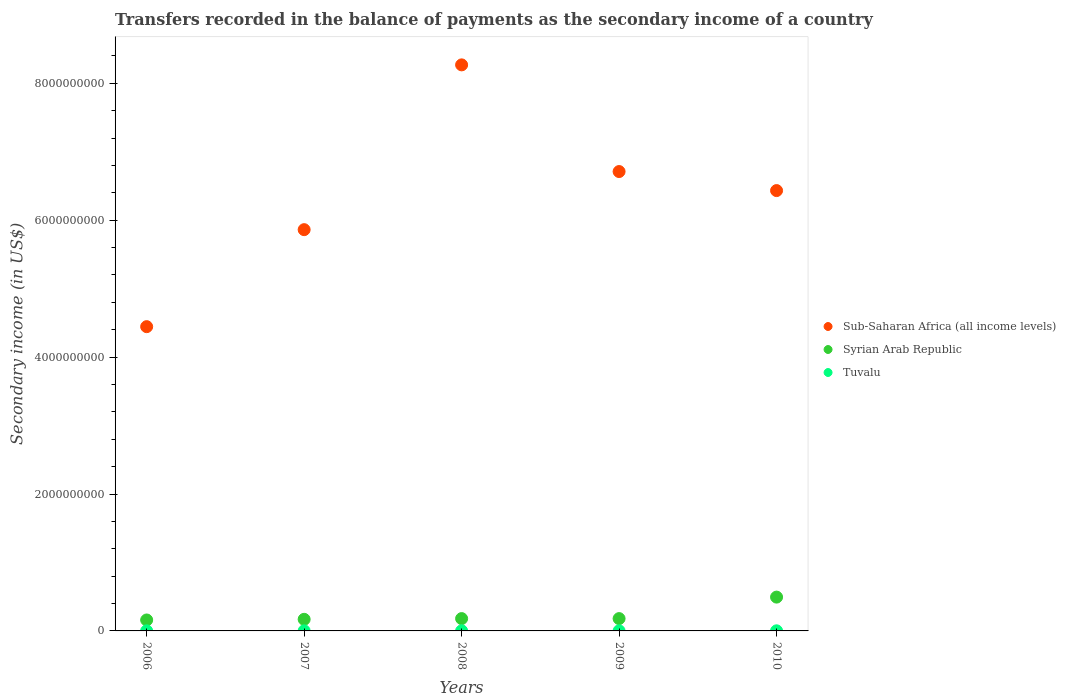How many different coloured dotlines are there?
Offer a terse response. 3. What is the secondary income of in Syrian Arab Republic in 2009?
Provide a succinct answer. 1.80e+08. Across all years, what is the maximum secondary income of in Tuvalu?
Your answer should be very brief. 1.61e+06. Across all years, what is the minimum secondary income of in Sub-Saharan Africa (all income levels)?
Make the answer very short. 4.45e+09. In which year was the secondary income of in Sub-Saharan Africa (all income levels) maximum?
Ensure brevity in your answer.  2008. In which year was the secondary income of in Tuvalu minimum?
Provide a succinct answer. 2006. What is the total secondary income of in Tuvalu in the graph?
Keep it short and to the point. 6.92e+06. What is the difference between the secondary income of in Sub-Saharan Africa (all income levels) in 2006 and that in 2010?
Offer a terse response. -1.99e+09. What is the difference between the secondary income of in Tuvalu in 2007 and the secondary income of in Sub-Saharan Africa (all income levels) in 2010?
Your answer should be very brief. -6.43e+09. What is the average secondary income of in Sub-Saharan Africa (all income levels) per year?
Offer a very short reply. 6.34e+09. In the year 2006, what is the difference between the secondary income of in Tuvalu and secondary income of in Sub-Saharan Africa (all income levels)?
Provide a short and direct response. -4.44e+09. In how many years, is the secondary income of in Syrian Arab Republic greater than 800000000 US$?
Your answer should be compact. 0. What is the ratio of the secondary income of in Syrian Arab Republic in 2006 to that in 2008?
Offer a terse response. 0.89. Is the secondary income of in Sub-Saharan Africa (all income levels) in 2006 less than that in 2007?
Offer a very short reply. Yes. What is the difference between the highest and the second highest secondary income of in Syrian Arab Republic?
Give a very brief answer. 3.14e+08. What is the difference between the highest and the lowest secondary income of in Tuvalu?
Offer a terse response. 4.24e+05. In how many years, is the secondary income of in Sub-Saharan Africa (all income levels) greater than the average secondary income of in Sub-Saharan Africa (all income levels) taken over all years?
Your answer should be compact. 3. Is the sum of the secondary income of in Syrian Arab Republic in 2006 and 2007 greater than the maximum secondary income of in Tuvalu across all years?
Your answer should be compact. Yes. Is the secondary income of in Sub-Saharan Africa (all income levels) strictly less than the secondary income of in Tuvalu over the years?
Make the answer very short. No. How many dotlines are there?
Keep it short and to the point. 3. How many years are there in the graph?
Offer a terse response. 5. Are the values on the major ticks of Y-axis written in scientific E-notation?
Your response must be concise. No. Does the graph contain grids?
Offer a terse response. No. How are the legend labels stacked?
Offer a terse response. Vertical. What is the title of the graph?
Your answer should be compact. Transfers recorded in the balance of payments as the secondary income of a country. Does "Burkina Faso" appear as one of the legend labels in the graph?
Your answer should be compact. No. What is the label or title of the X-axis?
Provide a succinct answer. Years. What is the label or title of the Y-axis?
Your answer should be compact. Secondary income (in US$). What is the Secondary income (in US$) in Sub-Saharan Africa (all income levels) in 2006?
Provide a succinct answer. 4.45e+09. What is the Secondary income (in US$) in Syrian Arab Republic in 2006?
Your answer should be very brief. 1.60e+08. What is the Secondary income (in US$) in Tuvalu in 2006?
Give a very brief answer. 1.19e+06. What is the Secondary income (in US$) of Sub-Saharan Africa (all income levels) in 2007?
Your answer should be compact. 5.86e+09. What is the Secondary income (in US$) of Syrian Arab Republic in 2007?
Offer a terse response. 1.70e+08. What is the Secondary income (in US$) in Tuvalu in 2007?
Provide a short and direct response. 1.32e+06. What is the Secondary income (in US$) in Sub-Saharan Africa (all income levels) in 2008?
Give a very brief answer. 8.27e+09. What is the Secondary income (in US$) in Syrian Arab Republic in 2008?
Make the answer very short. 1.80e+08. What is the Secondary income (in US$) of Tuvalu in 2008?
Offer a terse response. 1.46e+06. What is the Secondary income (in US$) of Sub-Saharan Africa (all income levels) in 2009?
Your response must be concise. 6.71e+09. What is the Secondary income (in US$) of Syrian Arab Republic in 2009?
Ensure brevity in your answer.  1.80e+08. What is the Secondary income (in US$) of Tuvalu in 2009?
Provide a short and direct response. 1.33e+06. What is the Secondary income (in US$) of Sub-Saharan Africa (all income levels) in 2010?
Your answer should be very brief. 6.43e+09. What is the Secondary income (in US$) of Syrian Arab Republic in 2010?
Ensure brevity in your answer.  4.94e+08. What is the Secondary income (in US$) of Tuvalu in 2010?
Your answer should be compact. 1.61e+06. Across all years, what is the maximum Secondary income (in US$) of Sub-Saharan Africa (all income levels)?
Your answer should be very brief. 8.27e+09. Across all years, what is the maximum Secondary income (in US$) of Syrian Arab Republic?
Provide a succinct answer. 4.94e+08. Across all years, what is the maximum Secondary income (in US$) in Tuvalu?
Ensure brevity in your answer.  1.61e+06. Across all years, what is the minimum Secondary income (in US$) of Sub-Saharan Africa (all income levels)?
Make the answer very short. 4.45e+09. Across all years, what is the minimum Secondary income (in US$) of Syrian Arab Republic?
Offer a very short reply. 1.60e+08. Across all years, what is the minimum Secondary income (in US$) in Tuvalu?
Your answer should be compact. 1.19e+06. What is the total Secondary income (in US$) of Sub-Saharan Africa (all income levels) in the graph?
Provide a short and direct response. 3.17e+1. What is the total Secondary income (in US$) of Syrian Arab Republic in the graph?
Provide a short and direct response. 1.18e+09. What is the total Secondary income (in US$) of Tuvalu in the graph?
Keep it short and to the point. 6.92e+06. What is the difference between the Secondary income (in US$) of Sub-Saharan Africa (all income levels) in 2006 and that in 2007?
Provide a succinct answer. -1.42e+09. What is the difference between the Secondary income (in US$) of Syrian Arab Republic in 2006 and that in 2007?
Provide a succinct answer. -9.50e+06. What is the difference between the Secondary income (in US$) in Tuvalu in 2006 and that in 2007?
Keep it short and to the point. -1.27e+05. What is the difference between the Secondary income (in US$) in Sub-Saharan Africa (all income levels) in 2006 and that in 2008?
Offer a very short reply. -3.82e+09. What is the difference between the Secondary income (in US$) in Syrian Arab Republic in 2006 and that in 2008?
Provide a short and direct response. -2.00e+07. What is the difference between the Secondary income (in US$) of Tuvalu in 2006 and that in 2008?
Keep it short and to the point. -2.72e+05. What is the difference between the Secondary income (in US$) in Sub-Saharan Africa (all income levels) in 2006 and that in 2009?
Provide a short and direct response. -2.27e+09. What is the difference between the Secondary income (in US$) of Syrian Arab Republic in 2006 and that in 2009?
Provide a succinct answer. -2.00e+07. What is the difference between the Secondary income (in US$) in Tuvalu in 2006 and that in 2009?
Your answer should be compact. -1.44e+05. What is the difference between the Secondary income (in US$) of Sub-Saharan Africa (all income levels) in 2006 and that in 2010?
Offer a very short reply. -1.99e+09. What is the difference between the Secondary income (in US$) of Syrian Arab Republic in 2006 and that in 2010?
Offer a very short reply. -3.34e+08. What is the difference between the Secondary income (in US$) in Tuvalu in 2006 and that in 2010?
Make the answer very short. -4.24e+05. What is the difference between the Secondary income (in US$) of Sub-Saharan Africa (all income levels) in 2007 and that in 2008?
Your answer should be compact. -2.41e+09. What is the difference between the Secondary income (in US$) of Syrian Arab Republic in 2007 and that in 2008?
Keep it short and to the point. -1.05e+07. What is the difference between the Secondary income (in US$) of Tuvalu in 2007 and that in 2008?
Your answer should be very brief. -1.44e+05. What is the difference between the Secondary income (in US$) of Sub-Saharan Africa (all income levels) in 2007 and that in 2009?
Keep it short and to the point. -8.49e+08. What is the difference between the Secondary income (in US$) of Syrian Arab Republic in 2007 and that in 2009?
Offer a very short reply. -1.05e+07. What is the difference between the Secondary income (in US$) in Tuvalu in 2007 and that in 2009?
Offer a very short reply. -1.69e+04. What is the difference between the Secondary income (in US$) in Sub-Saharan Africa (all income levels) in 2007 and that in 2010?
Give a very brief answer. -5.71e+08. What is the difference between the Secondary income (in US$) of Syrian Arab Republic in 2007 and that in 2010?
Offer a very short reply. -3.24e+08. What is the difference between the Secondary income (in US$) of Tuvalu in 2007 and that in 2010?
Provide a short and direct response. -2.97e+05. What is the difference between the Secondary income (in US$) in Sub-Saharan Africa (all income levels) in 2008 and that in 2009?
Your answer should be very brief. 1.56e+09. What is the difference between the Secondary income (in US$) of Syrian Arab Republic in 2008 and that in 2009?
Ensure brevity in your answer.  0. What is the difference between the Secondary income (in US$) in Tuvalu in 2008 and that in 2009?
Provide a succinct answer. 1.27e+05. What is the difference between the Secondary income (in US$) of Sub-Saharan Africa (all income levels) in 2008 and that in 2010?
Provide a short and direct response. 1.84e+09. What is the difference between the Secondary income (in US$) in Syrian Arab Republic in 2008 and that in 2010?
Provide a succinct answer. -3.14e+08. What is the difference between the Secondary income (in US$) in Tuvalu in 2008 and that in 2010?
Keep it short and to the point. -1.53e+05. What is the difference between the Secondary income (in US$) of Sub-Saharan Africa (all income levels) in 2009 and that in 2010?
Make the answer very short. 2.78e+08. What is the difference between the Secondary income (in US$) of Syrian Arab Republic in 2009 and that in 2010?
Give a very brief answer. -3.14e+08. What is the difference between the Secondary income (in US$) in Tuvalu in 2009 and that in 2010?
Make the answer very short. -2.80e+05. What is the difference between the Secondary income (in US$) of Sub-Saharan Africa (all income levels) in 2006 and the Secondary income (in US$) of Syrian Arab Republic in 2007?
Offer a very short reply. 4.28e+09. What is the difference between the Secondary income (in US$) in Sub-Saharan Africa (all income levels) in 2006 and the Secondary income (in US$) in Tuvalu in 2007?
Offer a very short reply. 4.44e+09. What is the difference between the Secondary income (in US$) of Syrian Arab Republic in 2006 and the Secondary income (in US$) of Tuvalu in 2007?
Offer a very short reply. 1.59e+08. What is the difference between the Secondary income (in US$) in Sub-Saharan Africa (all income levels) in 2006 and the Secondary income (in US$) in Syrian Arab Republic in 2008?
Ensure brevity in your answer.  4.27e+09. What is the difference between the Secondary income (in US$) of Sub-Saharan Africa (all income levels) in 2006 and the Secondary income (in US$) of Tuvalu in 2008?
Provide a short and direct response. 4.44e+09. What is the difference between the Secondary income (in US$) of Syrian Arab Republic in 2006 and the Secondary income (in US$) of Tuvalu in 2008?
Keep it short and to the point. 1.59e+08. What is the difference between the Secondary income (in US$) of Sub-Saharan Africa (all income levels) in 2006 and the Secondary income (in US$) of Syrian Arab Republic in 2009?
Provide a succinct answer. 4.27e+09. What is the difference between the Secondary income (in US$) in Sub-Saharan Africa (all income levels) in 2006 and the Secondary income (in US$) in Tuvalu in 2009?
Your answer should be compact. 4.44e+09. What is the difference between the Secondary income (in US$) of Syrian Arab Republic in 2006 and the Secondary income (in US$) of Tuvalu in 2009?
Offer a terse response. 1.59e+08. What is the difference between the Secondary income (in US$) in Sub-Saharan Africa (all income levels) in 2006 and the Secondary income (in US$) in Syrian Arab Republic in 2010?
Keep it short and to the point. 3.95e+09. What is the difference between the Secondary income (in US$) in Sub-Saharan Africa (all income levels) in 2006 and the Secondary income (in US$) in Tuvalu in 2010?
Keep it short and to the point. 4.44e+09. What is the difference between the Secondary income (in US$) of Syrian Arab Republic in 2006 and the Secondary income (in US$) of Tuvalu in 2010?
Provide a short and direct response. 1.58e+08. What is the difference between the Secondary income (in US$) of Sub-Saharan Africa (all income levels) in 2007 and the Secondary income (in US$) of Syrian Arab Republic in 2008?
Give a very brief answer. 5.68e+09. What is the difference between the Secondary income (in US$) in Sub-Saharan Africa (all income levels) in 2007 and the Secondary income (in US$) in Tuvalu in 2008?
Provide a short and direct response. 5.86e+09. What is the difference between the Secondary income (in US$) of Syrian Arab Republic in 2007 and the Secondary income (in US$) of Tuvalu in 2008?
Your answer should be very brief. 1.68e+08. What is the difference between the Secondary income (in US$) of Sub-Saharan Africa (all income levels) in 2007 and the Secondary income (in US$) of Syrian Arab Republic in 2009?
Offer a very short reply. 5.68e+09. What is the difference between the Secondary income (in US$) in Sub-Saharan Africa (all income levels) in 2007 and the Secondary income (in US$) in Tuvalu in 2009?
Keep it short and to the point. 5.86e+09. What is the difference between the Secondary income (in US$) in Syrian Arab Republic in 2007 and the Secondary income (in US$) in Tuvalu in 2009?
Your response must be concise. 1.68e+08. What is the difference between the Secondary income (in US$) of Sub-Saharan Africa (all income levels) in 2007 and the Secondary income (in US$) of Syrian Arab Republic in 2010?
Offer a terse response. 5.37e+09. What is the difference between the Secondary income (in US$) in Sub-Saharan Africa (all income levels) in 2007 and the Secondary income (in US$) in Tuvalu in 2010?
Give a very brief answer. 5.86e+09. What is the difference between the Secondary income (in US$) of Syrian Arab Republic in 2007 and the Secondary income (in US$) of Tuvalu in 2010?
Your response must be concise. 1.68e+08. What is the difference between the Secondary income (in US$) in Sub-Saharan Africa (all income levels) in 2008 and the Secondary income (in US$) in Syrian Arab Republic in 2009?
Keep it short and to the point. 8.09e+09. What is the difference between the Secondary income (in US$) of Sub-Saharan Africa (all income levels) in 2008 and the Secondary income (in US$) of Tuvalu in 2009?
Your answer should be compact. 8.27e+09. What is the difference between the Secondary income (in US$) in Syrian Arab Republic in 2008 and the Secondary income (in US$) in Tuvalu in 2009?
Provide a short and direct response. 1.79e+08. What is the difference between the Secondary income (in US$) of Sub-Saharan Africa (all income levels) in 2008 and the Secondary income (in US$) of Syrian Arab Republic in 2010?
Provide a succinct answer. 7.78e+09. What is the difference between the Secondary income (in US$) in Sub-Saharan Africa (all income levels) in 2008 and the Secondary income (in US$) in Tuvalu in 2010?
Give a very brief answer. 8.27e+09. What is the difference between the Secondary income (in US$) in Syrian Arab Republic in 2008 and the Secondary income (in US$) in Tuvalu in 2010?
Your answer should be very brief. 1.78e+08. What is the difference between the Secondary income (in US$) in Sub-Saharan Africa (all income levels) in 2009 and the Secondary income (in US$) in Syrian Arab Republic in 2010?
Your answer should be compact. 6.22e+09. What is the difference between the Secondary income (in US$) of Sub-Saharan Africa (all income levels) in 2009 and the Secondary income (in US$) of Tuvalu in 2010?
Provide a short and direct response. 6.71e+09. What is the difference between the Secondary income (in US$) in Syrian Arab Republic in 2009 and the Secondary income (in US$) in Tuvalu in 2010?
Ensure brevity in your answer.  1.78e+08. What is the average Secondary income (in US$) in Sub-Saharan Africa (all income levels) per year?
Keep it short and to the point. 6.34e+09. What is the average Secondary income (in US$) of Syrian Arab Republic per year?
Provide a succinct answer. 2.37e+08. What is the average Secondary income (in US$) in Tuvalu per year?
Make the answer very short. 1.38e+06. In the year 2006, what is the difference between the Secondary income (in US$) of Sub-Saharan Africa (all income levels) and Secondary income (in US$) of Syrian Arab Republic?
Give a very brief answer. 4.29e+09. In the year 2006, what is the difference between the Secondary income (in US$) in Sub-Saharan Africa (all income levels) and Secondary income (in US$) in Tuvalu?
Offer a terse response. 4.44e+09. In the year 2006, what is the difference between the Secondary income (in US$) of Syrian Arab Republic and Secondary income (in US$) of Tuvalu?
Give a very brief answer. 1.59e+08. In the year 2007, what is the difference between the Secondary income (in US$) of Sub-Saharan Africa (all income levels) and Secondary income (in US$) of Syrian Arab Republic?
Your answer should be very brief. 5.69e+09. In the year 2007, what is the difference between the Secondary income (in US$) in Sub-Saharan Africa (all income levels) and Secondary income (in US$) in Tuvalu?
Give a very brief answer. 5.86e+09. In the year 2007, what is the difference between the Secondary income (in US$) of Syrian Arab Republic and Secondary income (in US$) of Tuvalu?
Provide a succinct answer. 1.68e+08. In the year 2008, what is the difference between the Secondary income (in US$) of Sub-Saharan Africa (all income levels) and Secondary income (in US$) of Syrian Arab Republic?
Offer a terse response. 8.09e+09. In the year 2008, what is the difference between the Secondary income (in US$) of Sub-Saharan Africa (all income levels) and Secondary income (in US$) of Tuvalu?
Provide a short and direct response. 8.27e+09. In the year 2008, what is the difference between the Secondary income (in US$) in Syrian Arab Republic and Secondary income (in US$) in Tuvalu?
Your answer should be very brief. 1.79e+08. In the year 2009, what is the difference between the Secondary income (in US$) in Sub-Saharan Africa (all income levels) and Secondary income (in US$) in Syrian Arab Republic?
Give a very brief answer. 6.53e+09. In the year 2009, what is the difference between the Secondary income (in US$) in Sub-Saharan Africa (all income levels) and Secondary income (in US$) in Tuvalu?
Give a very brief answer. 6.71e+09. In the year 2009, what is the difference between the Secondary income (in US$) in Syrian Arab Republic and Secondary income (in US$) in Tuvalu?
Your response must be concise. 1.79e+08. In the year 2010, what is the difference between the Secondary income (in US$) of Sub-Saharan Africa (all income levels) and Secondary income (in US$) of Syrian Arab Republic?
Ensure brevity in your answer.  5.94e+09. In the year 2010, what is the difference between the Secondary income (in US$) in Sub-Saharan Africa (all income levels) and Secondary income (in US$) in Tuvalu?
Your answer should be very brief. 6.43e+09. In the year 2010, what is the difference between the Secondary income (in US$) in Syrian Arab Republic and Secondary income (in US$) in Tuvalu?
Ensure brevity in your answer.  4.92e+08. What is the ratio of the Secondary income (in US$) of Sub-Saharan Africa (all income levels) in 2006 to that in 2007?
Provide a short and direct response. 0.76. What is the ratio of the Secondary income (in US$) in Syrian Arab Republic in 2006 to that in 2007?
Keep it short and to the point. 0.94. What is the ratio of the Secondary income (in US$) in Tuvalu in 2006 to that in 2007?
Offer a terse response. 0.9. What is the ratio of the Secondary income (in US$) in Sub-Saharan Africa (all income levels) in 2006 to that in 2008?
Make the answer very short. 0.54. What is the ratio of the Secondary income (in US$) in Tuvalu in 2006 to that in 2008?
Your answer should be compact. 0.81. What is the ratio of the Secondary income (in US$) in Sub-Saharan Africa (all income levels) in 2006 to that in 2009?
Make the answer very short. 0.66. What is the ratio of the Secondary income (in US$) in Tuvalu in 2006 to that in 2009?
Your answer should be very brief. 0.89. What is the ratio of the Secondary income (in US$) in Sub-Saharan Africa (all income levels) in 2006 to that in 2010?
Make the answer very short. 0.69. What is the ratio of the Secondary income (in US$) in Syrian Arab Republic in 2006 to that in 2010?
Offer a terse response. 0.32. What is the ratio of the Secondary income (in US$) of Tuvalu in 2006 to that in 2010?
Keep it short and to the point. 0.74. What is the ratio of the Secondary income (in US$) in Sub-Saharan Africa (all income levels) in 2007 to that in 2008?
Make the answer very short. 0.71. What is the ratio of the Secondary income (in US$) of Syrian Arab Republic in 2007 to that in 2008?
Keep it short and to the point. 0.94. What is the ratio of the Secondary income (in US$) of Tuvalu in 2007 to that in 2008?
Provide a short and direct response. 0.9. What is the ratio of the Secondary income (in US$) in Sub-Saharan Africa (all income levels) in 2007 to that in 2009?
Give a very brief answer. 0.87. What is the ratio of the Secondary income (in US$) in Syrian Arab Republic in 2007 to that in 2009?
Ensure brevity in your answer.  0.94. What is the ratio of the Secondary income (in US$) in Tuvalu in 2007 to that in 2009?
Your answer should be very brief. 0.99. What is the ratio of the Secondary income (in US$) of Sub-Saharan Africa (all income levels) in 2007 to that in 2010?
Provide a succinct answer. 0.91. What is the ratio of the Secondary income (in US$) in Syrian Arab Republic in 2007 to that in 2010?
Your response must be concise. 0.34. What is the ratio of the Secondary income (in US$) of Tuvalu in 2007 to that in 2010?
Provide a succinct answer. 0.82. What is the ratio of the Secondary income (in US$) of Sub-Saharan Africa (all income levels) in 2008 to that in 2009?
Offer a terse response. 1.23. What is the ratio of the Secondary income (in US$) in Syrian Arab Republic in 2008 to that in 2009?
Your response must be concise. 1. What is the ratio of the Secondary income (in US$) in Tuvalu in 2008 to that in 2009?
Ensure brevity in your answer.  1.1. What is the ratio of the Secondary income (in US$) in Sub-Saharan Africa (all income levels) in 2008 to that in 2010?
Offer a very short reply. 1.29. What is the ratio of the Secondary income (in US$) in Syrian Arab Republic in 2008 to that in 2010?
Offer a very short reply. 0.36. What is the ratio of the Secondary income (in US$) in Tuvalu in 2008 to that in 2010?
Give a very brief answer. 0.91. What is the ratio of the Secondary income (in US$) of Sub-Saharan Africa (all income levels) in 2009 to that in 2010?
Provide a short and direct response. 1.04. What is the ratio of the Secondary income (in US$) in Syrian Arab Republic in 2009 to that in 2010?
Offer a very short reply. 0.36. What is the ratio of the Secondary income (in US$) of Tuvalu in 2009 to that in 2010?
Offer a very short reply. 0.83. What is the difference between the highest and the second highest Secondary income (in US$) of Sub-Saharan Africa (all income levels)?
Offer a terse response. 1.56e+09. What is the difference between the highest and the second highest Secondary income (in US$) of Syrian Arab Republic?
Give a very brief answer. 3.14e+08. What is the difference between the highest and the second highest Secondary income (in US$) of Tuvalu?
Keep it short and to the point. 1.53e+05. What is the difference between the highest and the lowest Secondary income (in US$) of Sub-Saharan Africa (all income levels)?
Make the answer very short. 3.82e+09. What is the difference between the highest and the lowest Secondary income (in US$) of Syrian Arab Republic?
Provide a short and direct response. 3.34e+08. What is the difference between the highest and the lowest Secondary income (in US$) of Tuvalu?
Your answer should be compact. 4.24e+05. 